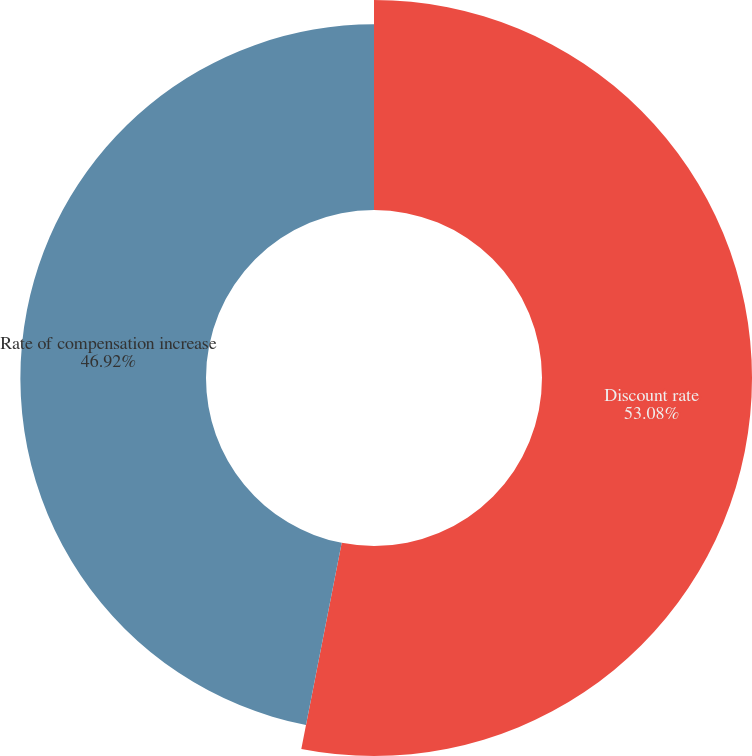Convert chart. <chart><loc_0><loc_0><loc_500><loc_500><pie_chart><fcel>Discount rate<fcel>Rate of compensation increase<nl><fcel>53.08%<fcel>46.92%<nl></chart> 